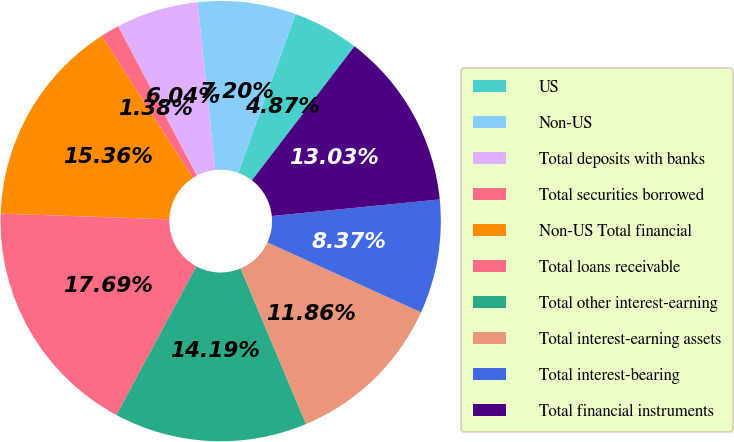Convert chart. <chart><loc_0><loc_0><loc_500><loc_500><pie_chart><fcel>US<fcel>Non-US<fcel>Total deposits with banks<fcel>Total securities borrowed<fcel>Non-US Total financial<fcel>Total loans receivable<fcel>Total other interest-earning<fcel>Total interest-earning assets<fcel>Total interest-bearing<fcel>Total financial instruments<nl><fcel>4.87%<fcel>7.2%<fcel>6.04%<fcel>1.38%<fcel>15.36%<fcel>17.69%<fcel>14.19%<fcel>11.86%<fcel>8.37%<fcel>13.03%<nl></chart> 